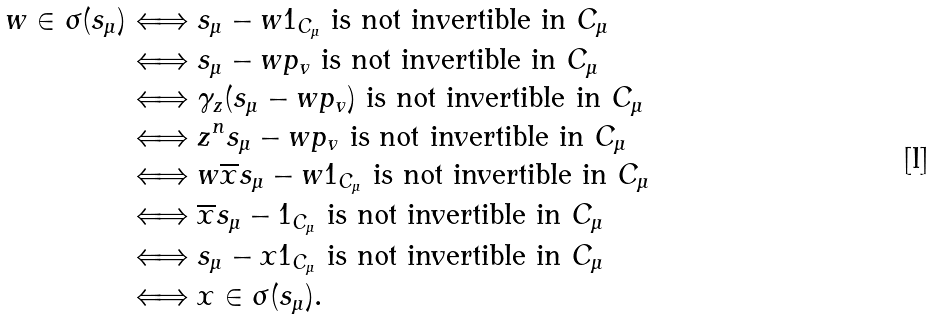<formula> <loc_0><loc_0><loc_500><loc_500>w \in \sigma ( s _ { \mu } ) & \Longleftrightarrow s _ { \mu } - w 1 _ { C _ { \mu } } \text { is not invertible in $C_{\mu}$} \\ & \Longleftrightarrow s _ { \mu } - w p _ { v } \text { is not invertible in $C_{\mu}$} \\ & \Longleftrightarrow \gamma _ { z } ( s _ { \mu } - w p _ { v } ) \text { is not invertible in $C_{\mu}$} \\ & \Longleftrightarrow z ^ { n } s _ { \mu } - w p _ { v } \text { is not invertible in $C_{\mu}$} \\ & \Longleftrightarrow w \overline { x } s _ { \mu } - w 1 _ { C _ { \mu } } \text { is not invertible in $C_{\mu}$} \\ & \Longleftrightarrow \overline { x } s _ { \mu } - 1 _ { C _ { \mu } } \text { is not invertible in $C_{\mu}$} \\ & \Longleftrightarrow s _ { \mu } - x 1 _ { C _ { \mu } } \text { is not invertible in $C_{\mu}$} \\ & \Longleftrightarrow x \in \sigma ( s _ { \mu } ) .</formula> 